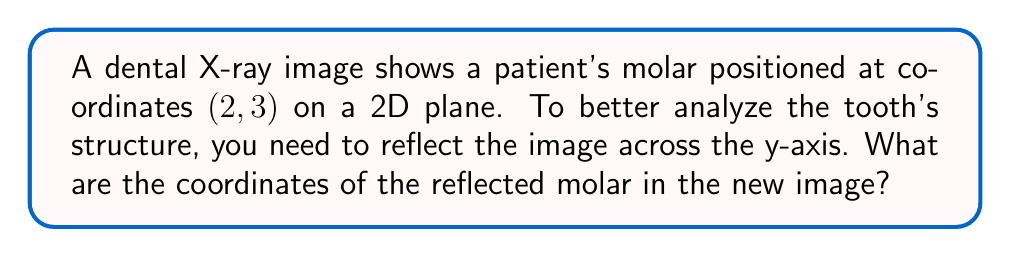Help me with this question. To reflect a point across the y-axis, we need to follow these steps:

1. Identify the original coordinates: The molar is at (2, 3).

2. Understand the reflection rule across the y-axis:
   - The x-coordinate changes sign
   - The y-coordinate remains the same

3. Apply the reflection:
   - New x-coordinate: $-2$ (the opposite of 2)
   - New y-coordinate: 3 (unchanged)

4. Write the new coordinates as an ordered pair: $(-2, 3)$

This reflection can be represented mathematically as a transformation:

$$(x, y) \rightarrow (-x, y)$$

Or as a matrix multiplication:

$$\begin{pmatrix} -1 & 0 \\ 0 & 1 \end{pmatrix} \begin{pmatrix} x \\ y \end{pmatrix} = \begin{pmatrix} -x \\ y \end{pmatrix}$$

Applying this to our specific case:

$$\begin{pmatrix} -1 & 0 \\ 0 & 1 \end{pmatrix} \begin{pmatrix} 2 \\ 3 \end{pmatrix} = \begin{pmatrix} -2 \\ 3 \end{pmatrix}$$

This transformation allows you to view the molar from a different perspective, which can be crucial for identifying dental issues that might not be apparent in the original image.
Answer: The coordinates of the reflected molar are $(-2, 3)$. 